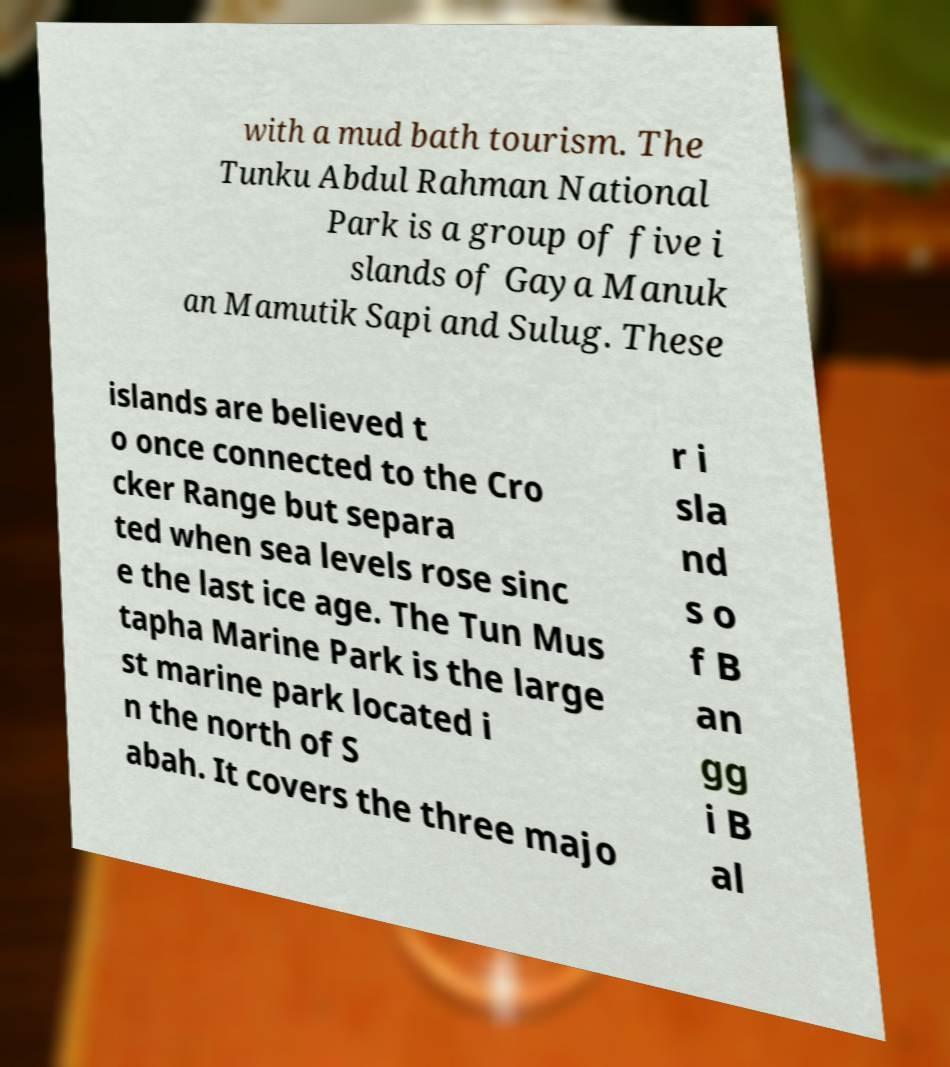For documentation purposes, I need the text within this image transcribed. Could you provide that? with a mud bath tourism. The Tunku Abdul Rahman National Park is a group of five i slands of Gaya Manuk an Mamutik Sapi and Sulug. These islands are believed t o once connected to the Cro cker Range but separa ted when sea levels rose sinc e the last ice age. The Tun Mus tapha Marine Park is the large st marine park located i n the north of S abah. It covers the three majo r i sla nd s o f B an gg i B al 